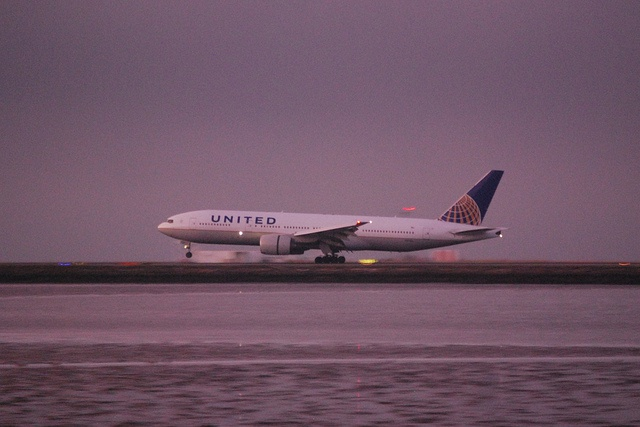Describe the objects in this image and their specific colors. I can see a airplane in purple, lightpink, black, and gray tones in this image. 